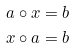Convert formula to latex. <formula><loc_0><loc_0><loc_500><loc_500>a \circ x & = b \\ x \circ a & = b</formula> 